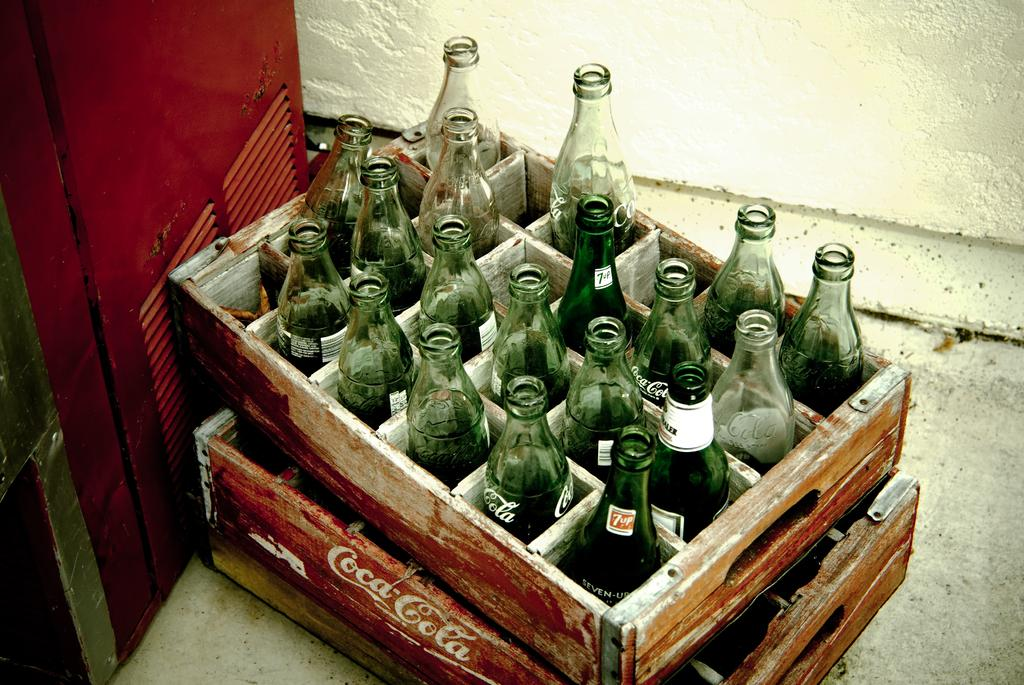What objects are present in the image? There are bottles in the image. How are the bottles arranged? The bottles are kept in a tray. What can be seen in the background of the image? There is a fridge and a wall in the background of the image. What type of sweater is hanging on the wall in the image? There is no sweater present in the image; only bottles, a tray, a fridge, and a wall are visible. 